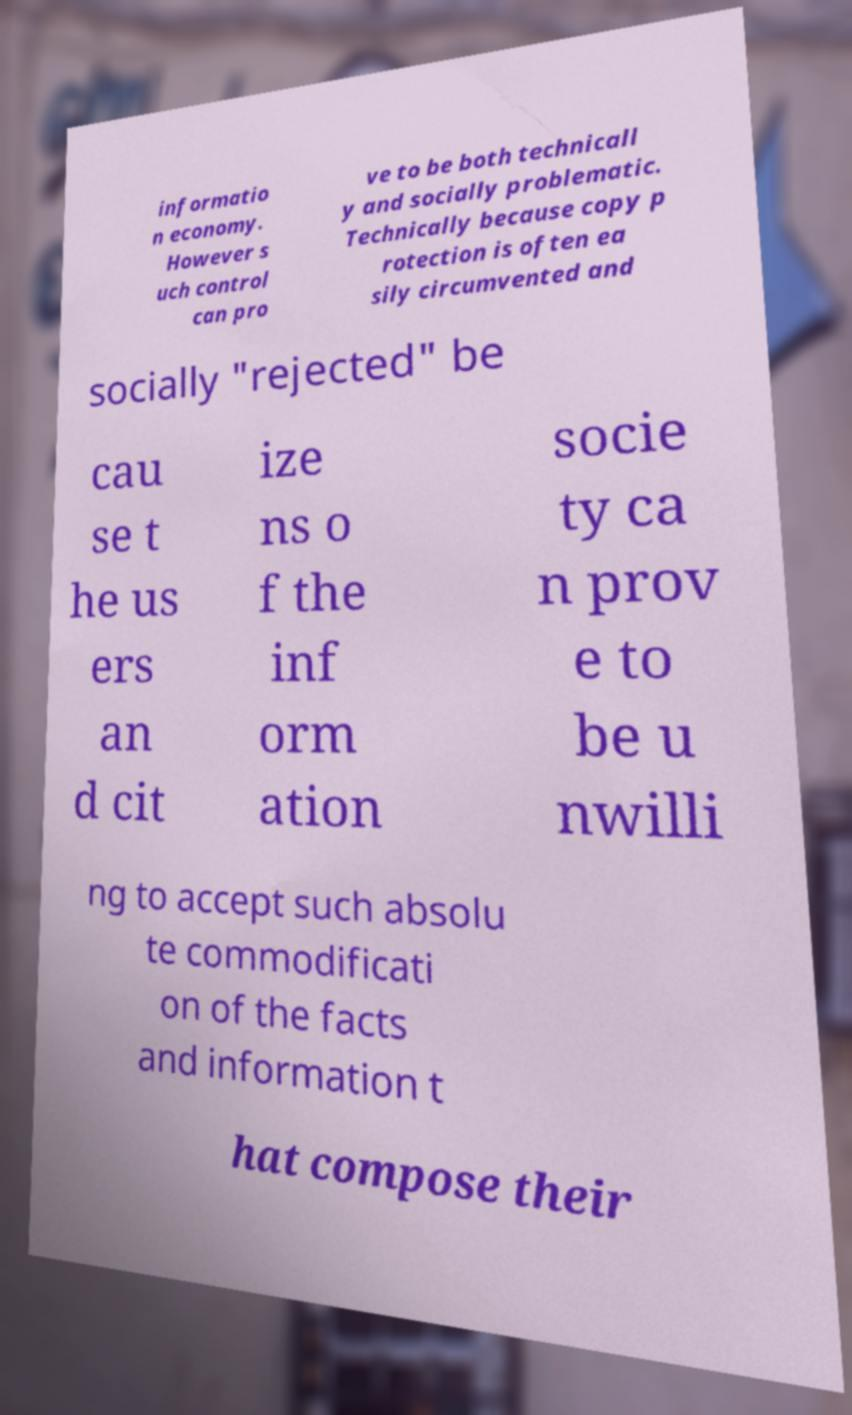Could you extract and type out the text from this image? informatio n economy. However s uch control can pro ve to be both technicall y and socially problematic. Technically because copy p rotection is often ea sily circumvented and socially "rejected" be cau se t he us ers an d cit ize ns o f the inf orm ation socie ty ca n prov e to be u nwilli ng to accept such absolu te commodificati on of the facts and information t hat compose their 